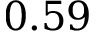<formula> <loc_0><loc_0><loc_500><loc_500>0 . 5 9</formula> 